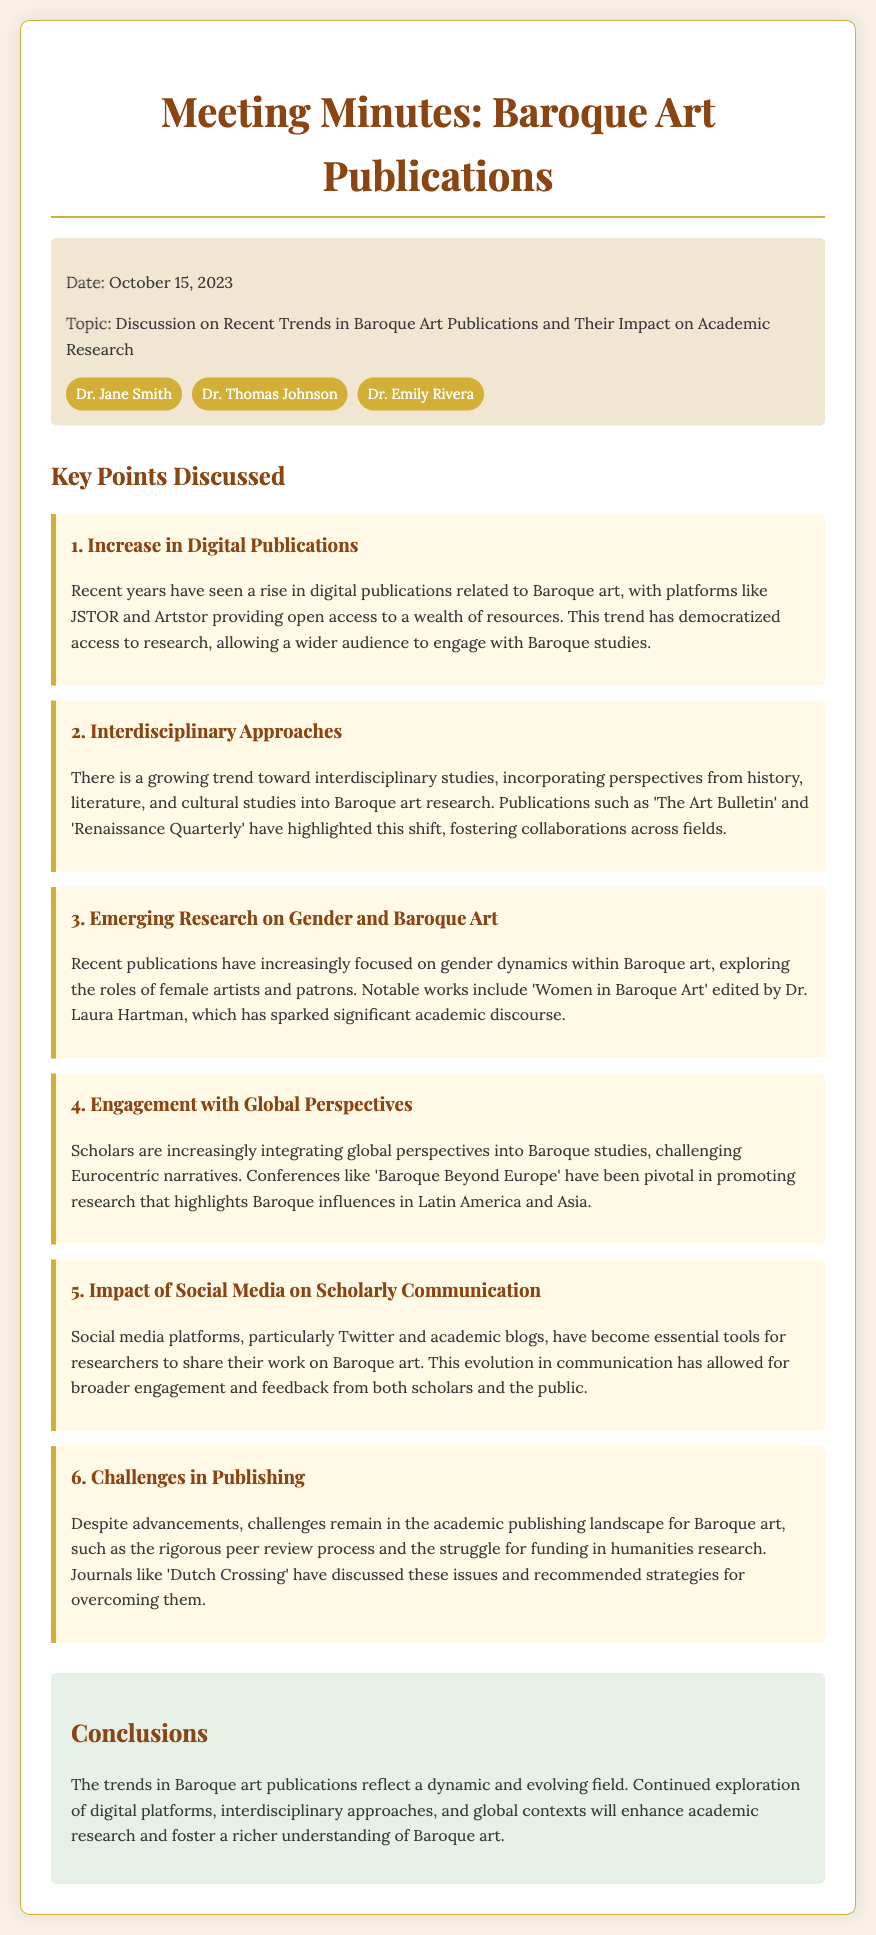What was the date of the meeting? The date of the meeting is specified in the meeting info section.
Answer: October 15, 2023 Who are the attendees present at the meeting? The attendees are listed under the meeting info section, showcasing who participated.
Answer: Dr. Jane Smith, Dr. Thomas Johnson, Dr. Emily Rivera What is one key trend in Baroque art publications discussed? The document outlines key points discussed in the meeting, indicating trends.
Answer: Increase in Digital Publications Which publication was mentioned as addressing gender dynamics in Baroque art? The document specifies notable works that focus on specific themes in Baroque art research.
Answer: Women in Baroque Art What is one challenge in publishing mentioned in the meeting? The document notes challenges faced in the academic publishing landscape for Baroque art.
Answer: Rigorous peer review process How has social media impacted scholarly communication according to the discussion? The key points discuss social media's role in facilitating communication among researchers.
Answer: Broader engagement and feedback 